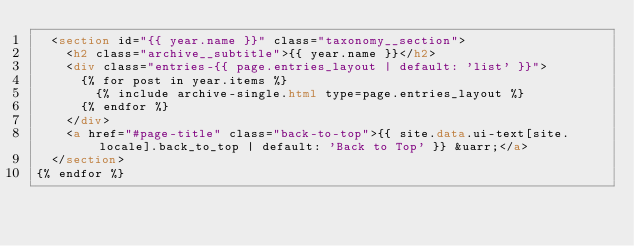Convert code to text. <code><loc_0><loc_0><loc_500><loc_500><_HTML_>  <section id="{{ year.name }}" class="taxonomy__section">
    <h2 class="archive__subtitle">{{ year.name }}</h2>
    <div class="entries-{{ page.entries_layout | default: 'list' }}">
      {% for post in year.items %}
        {% include archive-single.html type=page.entries_layout %}
      {% endfor %}
    </div>
    <a href="#page-title" class="back-to-top">{{ site.data.ui-text[site.locale].back_to_top | default: 'Back to Top' }} &uarr;</a>
  </section>
{% endfor %}</code> 